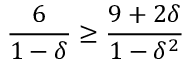Convert formula to latex. <formula><loc_0><loc_0><loc_500><loc_500>{ \frac { 6 } { 1 - \delta } } \geq { \frac { 9 + 2 \delta } { 1 - \delta ^ { 2 } } }</formula> 